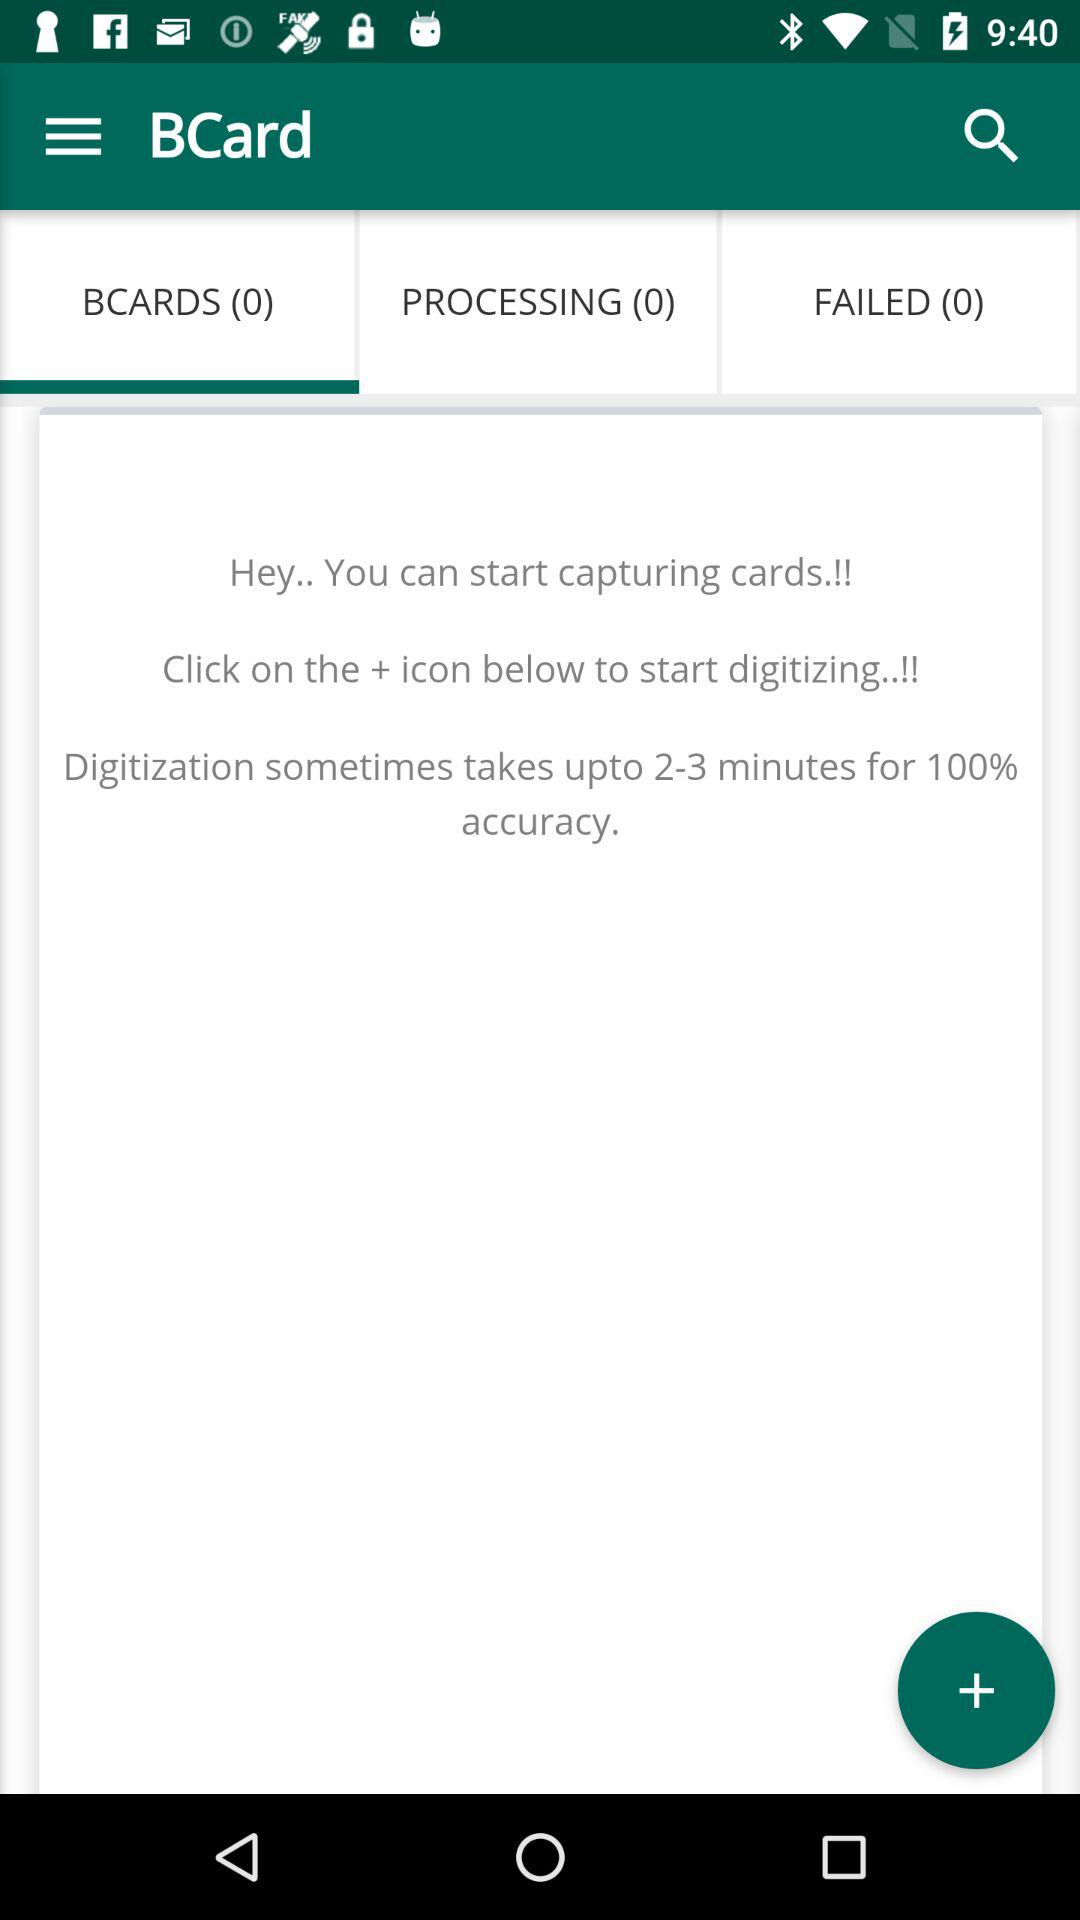Which tab is selected? The selected tab is "BCARDS (0)". 